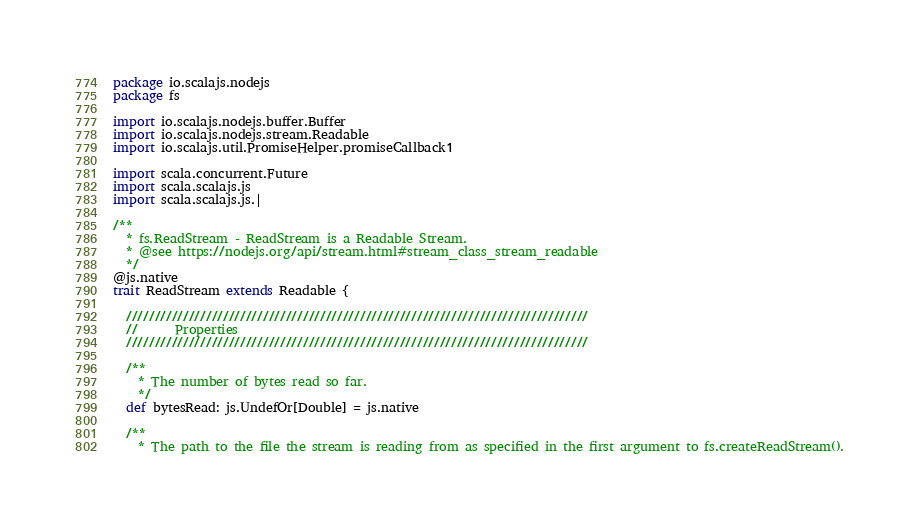<code> <loc_0><loc_0><loc_500><loc_500><_Scala_>package io.scalajs.nodejs
package fs

import io.scalajs.nodejs.buffer.Buffer
import io.scalajs.nodejs.stream.Readable
import io.scalajs.util.PromiseHelper.promiseCallback1

import scala.concurrent.Future
import scala.scalajs.js
import scala.scalajs.js.|

/**
  * fs.ReadStream - ReadStream is a Readable Stream.
  * @see https://nodejs.org/api/stream.html#stream_class_stream_readable
  */
@js.native
trait ReadStream extends Readable {

  /////////////////////////////////////////////////////////////////////////////////
  //      Properties
  /////////////////////////////////////////////////////////////////////////////////

  /**
    * The number of bytes read so far.
    */
  def bytesRead: js.UndefOr[Double] = js.native

  /**
    * The path to the file the stream is reading from as specified in the first argument to fs.createReadStream().</code> 